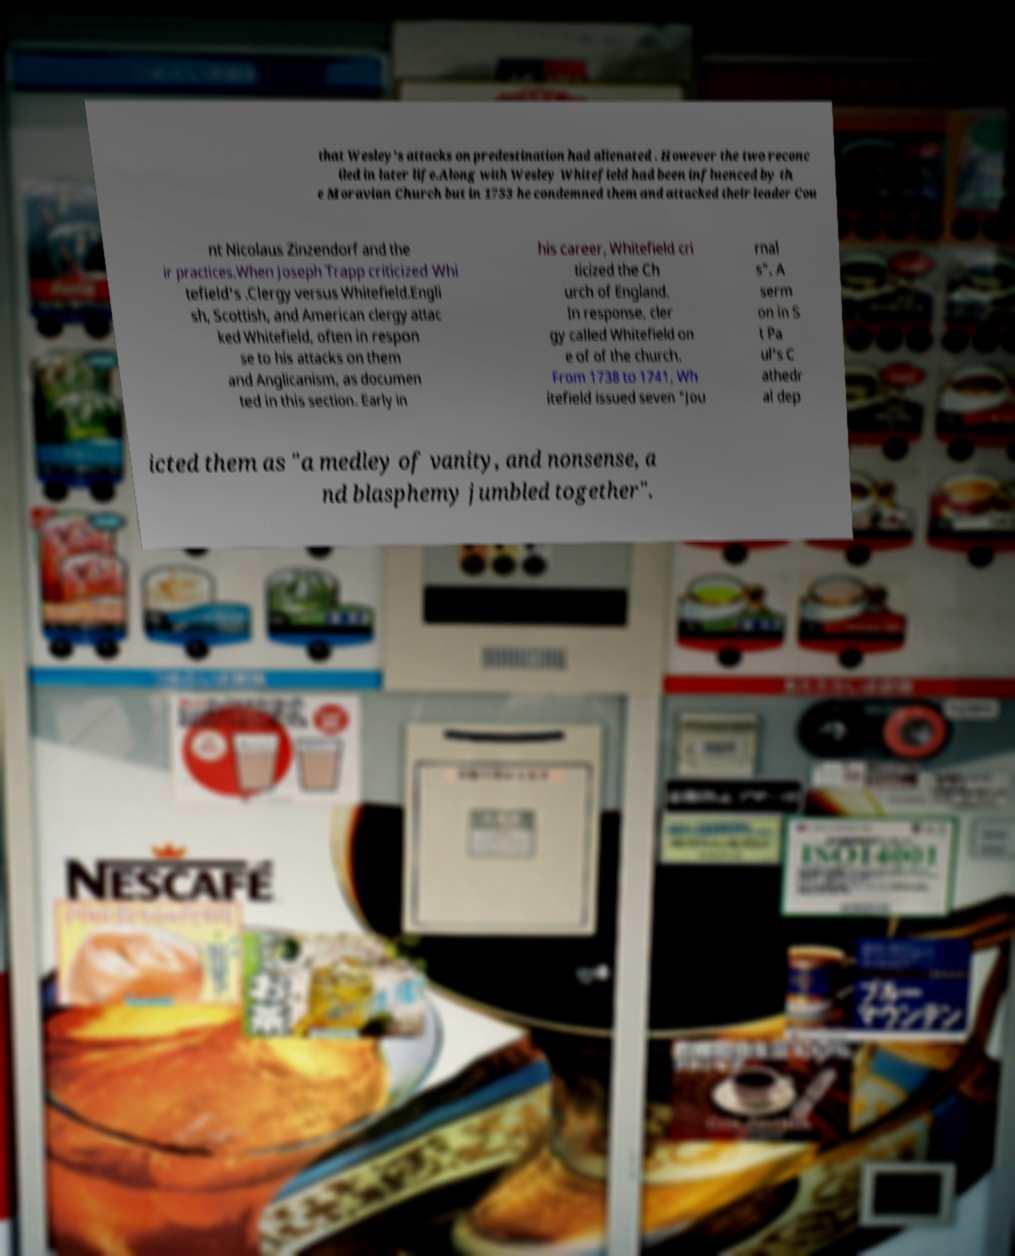For documentation purposes, I need the text within this image transcribed. Could you provide that? that Wesley's attacks on predestination had alienated . However the two reconc iled in later life.Along with Wesley Whitefield had been influenced by th e Moravian Church but in 1753 he condemned them and attacked their leader Cou nt Nicolaus Zinzendorf and the ir practices.When Joseph Trapp criticized Whi tefield's .Clergy versus Whitefield.Engli sh, Scottish, and American clergy attac ked Whitefield, often in respon se to his attacks on them and Anglicanism, as documen ted in this section. Early in his career, Whitefield cri ticized the Ch urch of England. In response, cler gy called Whitefield on e of of the church. From 1738 to 1741, Wh itefield issued seven "Jou rnal s". A serm on in S t Pa ul's C athedr al dep icted them as "a medley of vanity, and nonsense, a nd blasphemy jumbled together". 